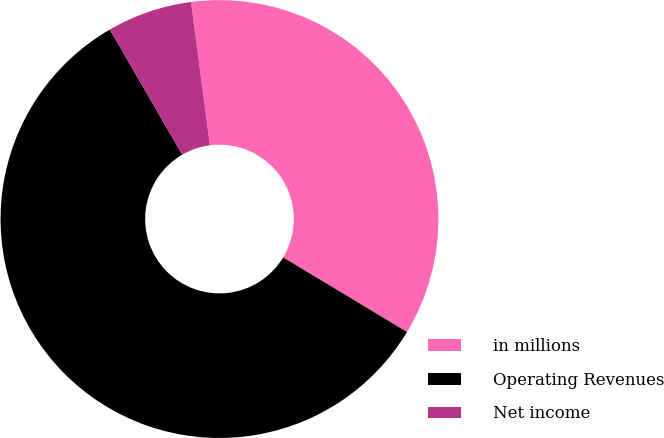Convert chart to OTSL. <chart><loc_0><loc_0><loc_500><loc_500><pie_chart><fcel>in millions<fcel>Operating Revenues<fcel>Net income<nl><fcel>35.7%<fcel>58.02%<fcel>6.28%<nl></chart> 